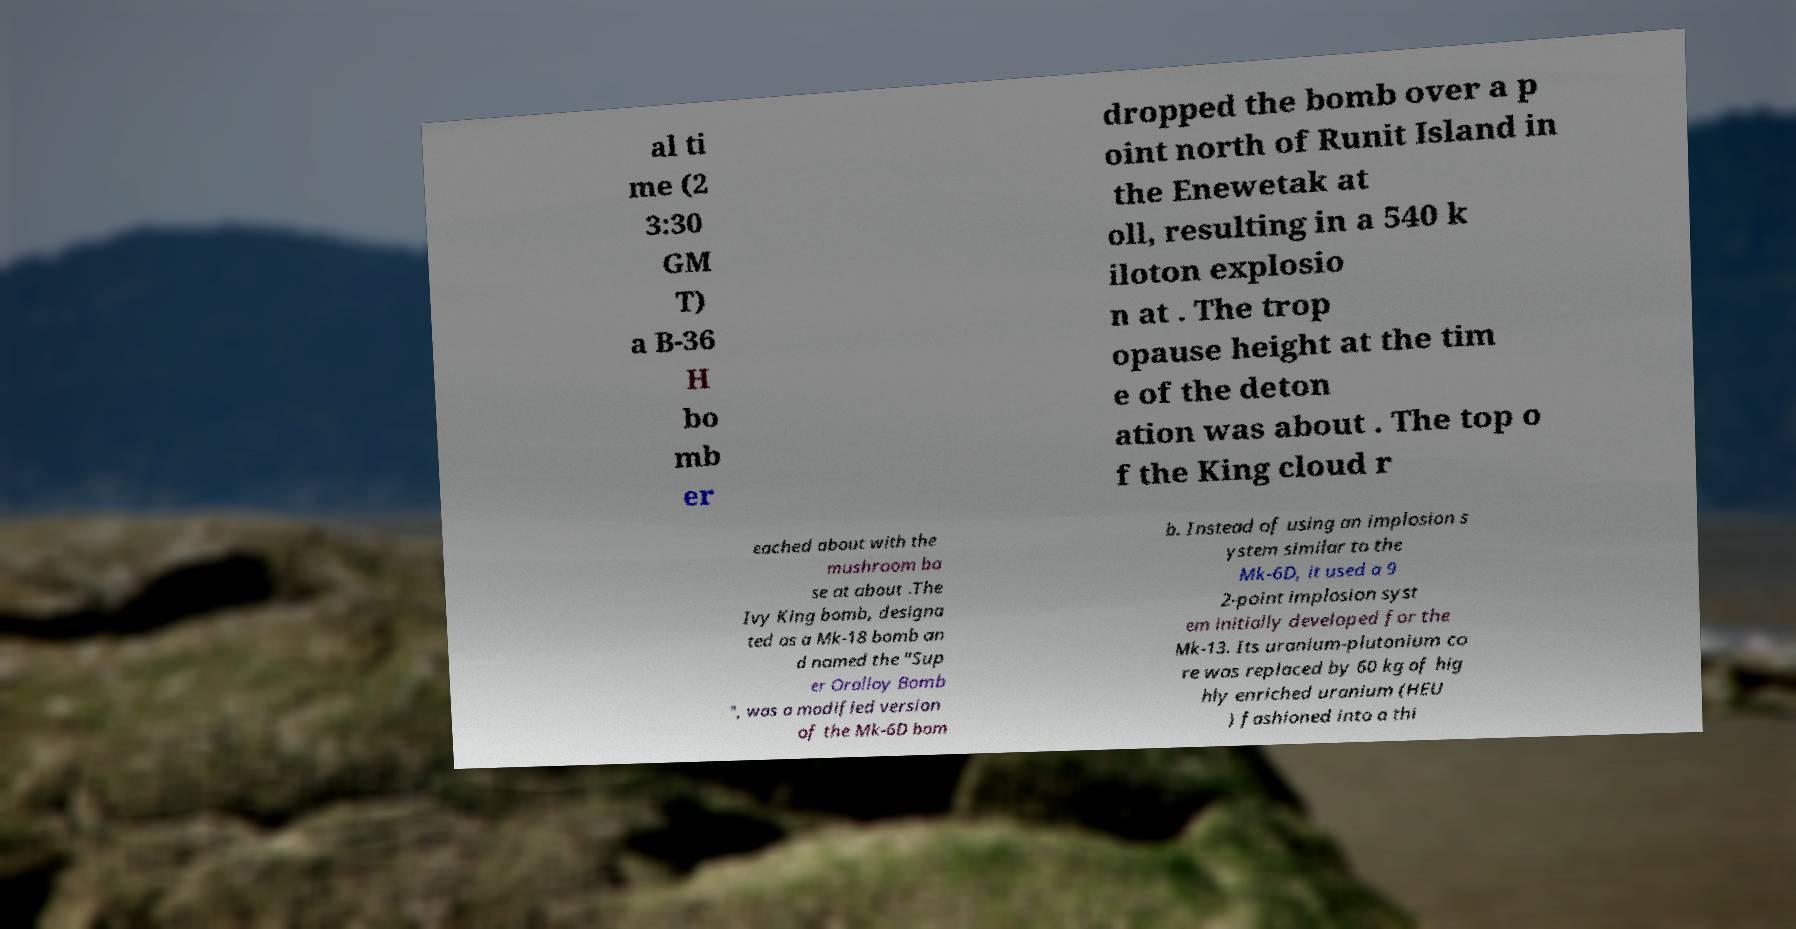For documentation purposes, I need the text within this image transcribed. Could you provide that? al ti me (2 3:30 GM T) a B-36 H bo mb er dropped the bomb over a p oint north of Runit Island in the Enewetak at oll, resulting in a 540 k iloton explosio n at . The trop opause height at the tim e of the deton ation was about . The top o f the King cloud r eached about with the mushroom ba se at about .The Ivy King bomb, designa ted as a Mk-18 bomb an d named the "Sup er Oralloy Bomb ", was a modified version of the Mk-6D bom b. Instead of using an implosion s ystem similar to the Mk-6D, it used a 9 2-point implosion syst em initially developed for the Mk-13. Its uranium-plutonium co re was replaced by 60 kg of hig hly enriched uranium (HEU ) fashioned into a thi 